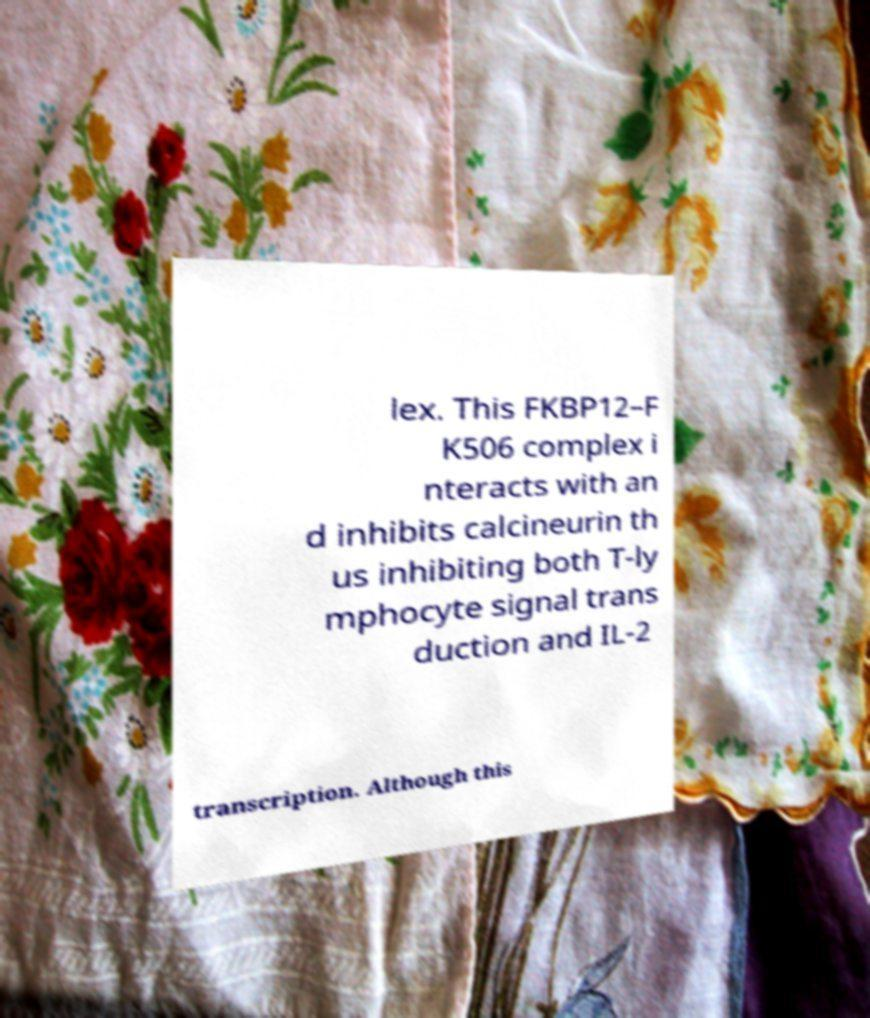Please identify and transcribe the text found in this image. lex. This FKBP12–F K506 complex i nteracts with an d inhibits calcineurin th us inhibiting both T-ly mphocyte signal trans duction and IL-2 transcription. Although this 